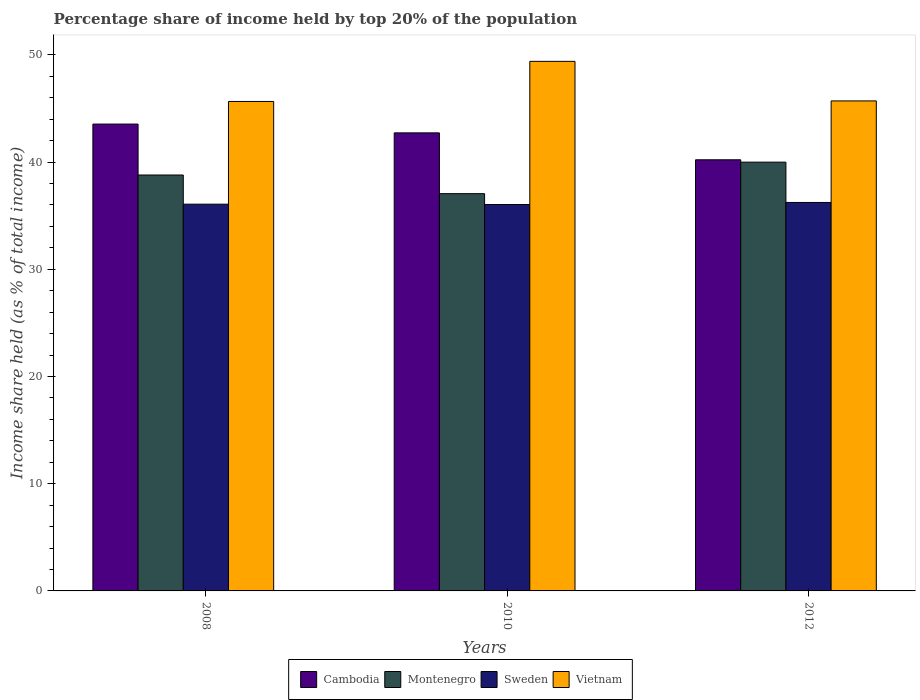How many different coloured bars are there?
Keep it short and to the point. 4. How many groups of bars are there?
Make the answer very short. 3. How many bars are there on the 1st tick from the left?
Provide a short and direct response. 4. What is the label of the 1st group of bars from the left?
Your answer should be very brief. 2008. In how many cases, is the number of bars for a given year not equal to the number of legend labels?
Your answer should be compact. 0. What is the percentage share of income held by top 20% of the population in Montenegro in 2012?
Your answer should be very brief. 39.99. Across all years, what is the maximum percentage share of income held by top 20% of the population in Sweden?
Ensure brevity in your answer.  36.23. Across all years, what is the minimum percentage share of income held by top 20% of the population in Vietnam?
Keep it short and to the point. 45.65. In which year was the percentage share of income held by top 20% of the population in Sweden maximum?
Keep it short and to the point. 2012. In which year was the percentage share of income held by top 20% of the population in Montenegro minimum?
Ensure brevity in your answer.  2010. What is the total percentage share of income held by top 20% of the population in Montenegro in the graph?
Give a very brief answer. 115.83. What is the difference between the percentage share of income held by top 20% of the population in Cambodia in 2010 and that in 2012?
Your answer should be compact. 2.51. What is the difference between the percentage share of income held by top 20% of the population in Sweden in 2008 and the percentage share of income held by top 20% of the population in Cambodia in 2012?
Keep it short and to the point. -4.14. What is the average percentage share of income held by top 20% of the population in Montenegro per year?
Offer a terse response. 38.61. In the year 2008, what is the difference between the percentage share of income held by top 20% of the population in Cambodia and percentage share of income held by top 20% of the population in Sweden?
Your answer should be very brief. 7.47. In how many years, is the percentage share of income held by top 20% of the population in Montenegro greater than 30 %?
Ensure brevity in your answer.  3. What is the ratio of the percentage share of income held by top 20% of the population in Vietnam in 2008 to that in 2010?
Make the answer very short. 0.92. Is the percentage share of income held by top 20% of the population in Cambodia in 2008 less than that in 2012?
Make the answer very short. No. Is the difference between the percentage share of income held by top 20% of the population in Cambodia in 2008 and 2012 greater than the difference between the percentage share of income held by top 20% of the population in Sweden in 2008 and 2012?
Give a very brief answer. Yes. What is the difference between the highest and the second highest percentage share of income held by top 20% of the population in Vietnam?
Give a very brief answer. 3.69. What is the difference between the highest and the lowest percentage share of income held by top 20% of the population in Sweden?
Give a very brief answer. 0.19. Is it the case that in every year, the sum of the percentage share of income held by top 20% of the population in Cambodia and percentage share of income held by top 20% of the population in Sweden is greater than the sum of percentage share of income held by top 20% of the population in Vietnam and percentage share of income held by top 20% of the population in Montenegro?
Your answer should be compact. Yes. What does the 4th bar from the left in 2010 represents?
Keep it short and to the point. Vietnam. What does the 4th bar from the right in 2008 represents?
Your answer should be very brief. Cambodia. Is it the case that in every year, the sum of the percentage share of income held by top 20% of the population in Montenegro and percentage share of income held by top 20% of the population in Sweden is greater than the percentage share of income held by top 20% of the population in Cambodia?
Your response must be concise. Yes. Are the values on the major ticks of Y-axis written in scientific E-notation?
Your response must be concise. No. Does the graph contain grids?
Give a very brief answer. No. Where does the legend appear in the graph?
Your answer should be compact. Bottom center. How many legend labels are there?
Offer a terse response. 4. How are the legend labels stacked?
Your answer should be very brief. Horizontal. What is the title of the graph?
Offer a very short reply. Percentage share of income held by top 20% of the population. Does "Lesotho" appear as one of the legend labels in the graph?
Keep it short and to the point. No. What is the label or title of the Y-axis?
Make the answer very short. Income share held (as % of total income). What is the Income share held (as % of total income) in Cambodia in 2008?
Your response must be concise. 43.54. What is the Income share held (as % of total income) in Montenegro in 2008?
Ensure brevity in your answer.  38.79. What is the Income share held (as % of total income) in Sweden in 2008?
Provide a short and direct response. 36.07. What is the Income share held (as % of total income) of Vietnam in 2008?
Provide a short and direct response. 45.65. What is the Income share held (as % of total income) in Cambodia in 2010?
Give a very brief answer. 42.72. What is the Income share held (as % of total income) in Montenegro in 2010?
Provide a succinct answer. 37.05. What is the Income share held (as % of total income) of Sweden in 2010?
Your answer should be very brief. 36.04. What is the Income share held (as % of total income) in Vietnam in 2010?
Your response must be concise. 49.39. What is the Income share held (as % of total income) in Cambodia in 2012?
Offer a very short reply. 40.21. What is the Income share held (as % of total income) of Montenegro in 2012?
Provide a short and direct response. 39.99. What is the Income share held (as % of total income) of Sweden in 2012?
Offer a very short reply. 36.23. What is the Income share held (as % of total income) in Vietnam in 2012?
Give a very brief answer. 45.7. Across all years, what is the maximum Income share held (as % of total income) in Cambodia?
Make the answer very short. 43.54. Across all years, what is the maximum Income share held (as % of total income) of Montenegro?
Keep it short and to the point. 39.99. Across all years, what is the maximum Income share held (as % of total income) in Sweden?
Give a very brief answer. 36.23. Across all years, what is the maximum Income share held (as % of total income) in Vietnam?
Offer a very short reply. 49.39. Across all years, what is the minimum Income share held (as % of total income) in Cambodia?
Provide a succinct answer. 40.21. Across all years, what is the minimum Income share held (as % of total income) of Montenegro?
Offer a very short reply. 37.05. Across all years, what is the minimum Income share held (as % of total income) in Sweden?
Offer a very short reply. 36.04. Across all years, what is the minimum Income share held (as % of total income) in Vietnam?
Ensure brevity in your answer.  45.65. What is the total Income share held (as % of total income) in Cambodia in the graph?
Ensure brevity in your answer.  126.47. What is the total Income share held (as % of total income) in Montenegro in the graph?
Give a very brief answer. 115.83. What is the total Income share held (as % of total income) in Sweden in the graph?
Provide a succinct answer. 108.34. What is the total Income share held (as % of total income) of Vietnam in the graph?
Your response must be concise. 140.74. What is the difference between the Income share held (as % of total income) of Cambodia in 2008 and that in 2010?
Give a very brief answer. 0.82. What is the difference between the Income share held (as % of total income) in Montenegro in 2008 and that in 2010?
Keep it short and to the point. 1.74. What is the difference between the Income share held (as % of total income) of Sweden in 2008 and that in 2010?
Make the answer very short. 0.03. What is the difference between the Income share held (as % of total income) of Vietnam in 2008 and that in 2010?
Offer a terse response. -3.74. What is the difference between the Income share held (as % of total income) in Cambodia in 2008 and that in 2012?
Provide a short and direct response. 3.33. What is the difference between the Income share held (as % of total income) of Montenegro in 2008 and that in 2012?
Your answer should be very brief. -1.2. What is the difference between the Income share held (as % of total income) in Sweden in 2008 and that in 2012?
Your response must be concise. -0.16. What is the difference between the Income share held (as % of total income) in Vietnam in 2008 and that in 2012?
Ensure brevity in your answer.  -0.05. What is the difference between the Income share held (as % of total income) in Cambodia in 2010 and that in 2012?
Offer a terse response. 2.51. What is the difference between the Income share held (as % of total income) of Montenegro in 2010 and that in 2012?
Make the answer very short. -2.94. What is the difference between the Income share held (as % of total income) of Sweden in 2010 and that in 2012?
Give a very brief answer. -0.19. What is the difference between the Income share held (as % of total income) of Vietnam in 2010 and that in 2012?
Provide a short and direct response. 3.69. What is the difference between the Income share held (as % of total income) in Cambodia in 2008 and the Income share held (as % of total income) in Montenegro in 2010?
Make the answer very short. 6.49. What is the difference between the Income share held (as % of total income) of Cambodia in 2008 and the Income share held (as % of total income) of Vietnam in 2010?
Provide a succinct answer. -5.85. What is the difference between the Income share held (as % of total income) in Montenegro in 2008 and the Income share held (as % of total income) in Sweden in 2010?
Your response must be concise. 2.75. What is the difference between the Income share held (as % of total income) in Sweden in 2008 and the Income share held (as % of total income) in Vietnam in 2010?
Offer a very short reply. -13.32. What is the difference between the Income share held (as % of total income) of Cambodia in 2008 and the Income share held (as % of total income) of Montenegro in 2012?
Provide a short and direct response. 3.55. What is the difference between the Income share held (as % of total income) in Cambodia in 2008 and the Income share held (as % of total income) in Sweden in 2012?
Offer a very short reply. 7.31. What is the difference between the Income share held (as % of total income) of Cambodia in 2008 and the Income share held (as % of total income) of Vietnam in 2012?
Keep it short and to the point. -2.16. What is the difference between the Income share held (as % of total income) of Montenegro in 2008 and the Income share held (as % of total income) of Sweden in 2012?
Make the answer very short. 2.56. What is the difference between the Income share held (as % of total income) in Montenegro in 2008 and the Income share held (as % of total income) in Vietnam in 2012?
Ensure brevity in your answer.  -6.91. What is the difference between the Income share held (as % of total income) of Sweden in 2008 and the Income share held (as % of total income) of Vietnam in 2012?
Provide a succinct answer. -9.63. What is the difference between the Income share held (as % of total income) of Cambodia in 2010 and the Income share held (as % of total income) of Montenegro in 2012?
Provide a short and direct response. 2.73. What is the difference between the Income share held (as % of total income) of Cambodia in 2010 and the Income share held (as % of total income) of Sweden in 2012?
Provide a short and direct response. 6.49. What is the difference between the Income share held (as % of total income) of Cambodia in 2010 and the Income share held (as % of total income) of Vietnam in 2012?
Provide a succinct answer. -2.98. What is the difference between the Income share held (as % of total income) of Montenegro in 2010 and the Income share held (as % of total income) of Sweden in 2012?
Provide a short and direct response. 0.82. What is the difference between the Income share held (as % of total income) in Montenegro in 2010 and the Income share held (as % of total income) in Vietnam in 2012?
Ensure brevity in your answer.  -8.65. What is the difference between the Income share held (as % of total income) in Sweden in 2010 and the Income share held (as % of total income) in Vietnam in 2012?
Ensure brevity in your answer.  -9.66. What is the average Income share held (as % of total income) in Cambodia per year?
Offer a very short reply. 42.16. What is the average Income share held (as % of total income) of Montenegro per year?
Provide a succinct answer. 38.61. What is the average Income share held (as % of total income) of Sweden per year?
Provide a succinct answer. 36.11. What is the average Income share held (as % of total income) in Vietnam per year?
Your response must be concise. 46.91. In the year 2008, what is the difference between the Income share held (as % of total income) in Cambodia and Income share held (as % of total income) in Montenegro?
Provide a succinct answer. 4.75. In the year 2008, what is the difference between the Income share held (as % of total income) in Cambodia and Income share held (as % of total income) in Sweden?
Offer a very short reply. 7.47. In the year 2008, what is the difference between the Income share held (as % of total income) of Cambodia and Income share held (as % of total income) of Vietnam?
Your answer should be compact. -2.11. In the year 2008, what is the difference between the Income share held (as % of total income) in Montenegro and Income share held (as % of total income) in Sweden?
Provide a succinct answer. 2.72. In the year 2008, what is the difference between the Income share held (as % of total income) of Montenegro and Income share held (as % of total income) of Vietnam?
Your answer should be very brief. -6.86. In the year 2008, what is the difference between the Income share held (as % of total income) in Sweden and Income share held (as % of total income) in Vietnam?
Ensure brevity in your answer.  -9.58. In the year 2010, what is the difference between the Income share held (as % of total income) of Cambodia and Income share held (as % of total income) of Montenegro?
Your response must be concise. 5.67. In the year 2010, what is the difference between the Income share held (as % of total income) in Cambodia and Income share held (as % of total income) in Sweden?
Offer a very short reply. 6.68. In the year 2010, what is the difference between the Income share held (as % of total income) of Cambodia and Income share held (as % of total income) of Vietnam?
Ensure brevity in your answer.  -6.67. In the year 2010, what is the difference between the Income share held (as % of total income) of Montenegro and Income share held (as % of total income) of Sweden?
Make the answer very short. 1.01. In the year 2010, what is the difference between the Income share held (as % of total income) in Montenegro and Income share held (as % of total income) in Vietnam?
Your answer should be compact. -12.34. In the year 2010, what is the difference between the Income share held (as % of total income) in Sweden and Income share held (as % of total income) in Vietnam?
Your response must be concise. -13.35. In the year 2012, what is the difference between the Income share held (as % of total income) in Cambodia and Income share held (as % of total income) in Montenegro?
Offer a terse response. 0.22. In the year 2012, what is the difference between the Income share held (as % of total income) in Cambodia and Income share held (as % of total income) in Sweden?
Ensure brevity in your answer.  3.98. In the year 2012, what is the difference between the Income share held (as % of total income) of Cambodia and Income share held (as % of total income) of Vietnam?
Your answer should be very brief. -5.49. In the year 2012, what is the difference between the Income share held (as % of total income) of Montenegro and Income share held (as % of total income) of Sweden?
Give a very brief answer. 3.76. In the year 2012, what is the difference between the Income share held (as % of total income) of Montenegro and Income share held (as % of total income) of Vietnam?
Provide a succinct answer. -5.71. In the year 2012, what is the difference between the Income share held (as % of total income) in Sweden and Income share held (as % of total income) in Vietnam?
Keep it short and to the point. -9.47. What is the ratio of the Income share held (as % of total income) in Cambodia in 2008 to that in 2010?
Your response must be concise. 1.02. What is the ratio of the Income share held (as % of total income) of Montenegro in 2008 to that in 2010?
Give a very brief answer. 1.05. What is the ratio of the Income share held (as % of total income) in Vietnam in 2008 to that in 2010?
Ensure brevity in your answer.  0.92. What is the ratio of the Income share held (as % of total income) in Cambodia in 2008 to that in 2012?
Make the answer very short. 1.08. What is the ratio of the Income share held (as % of total income) in Montenegro in 2008 to that in 2012?
Keep it short and to the point. 0.97. What is the ratio of the Income share held (as % of total income) in Vietnam in 2008 to that in 2012?
Your answer should be very brief. 1. What is the ratio of the Income share held (as % of total income) in Cambodia in 2010 to that in 2012?
Your response must be concise. 1.06. What is the ratio of the Income share held (as % of total income) of Montenegro in 2010 to that in 2012?
Offer a very short reply. 0.93. What is the ratio of the Income share held (as % of total income) of Vietnam in 2010 to that in 2012?
Provide a succinct answer. 1.08. What is the difference between the highest and the second highest Income share held (as % of total income) in Cambodia?
Your response must be concise. 0.82. What is the difference between the highest and the second highest Income share held (as % of total income) of Montenegro?
Ensure brevity in your answer.  1.2. What is the difference between the highest and the second highest Income share held (as % of total income) of Sweden?
Make the answer very short. 0.16. What is the difference between the highest and the second highest Income share held (as % of total income) in Vietnam?
Offer a terse response. 3.69. What is the difference between the highest and the lowest Income share held (as % of total income) of Cambodia?
Your answer should be compact. 3.33. What is the difference between the highest and the lowest Income share held (as % of total income) of Montenegro?
Your answer should be very brief. 2.94. What is the difference between the highest and the lowest Income share held (as % of total income) of Sweden?
Make the answer very short. 0.19. What is the difference between the highest and the lowest Income share held (as % of total income) of Vietnam?
Provide a succinct answer. 3.74. 